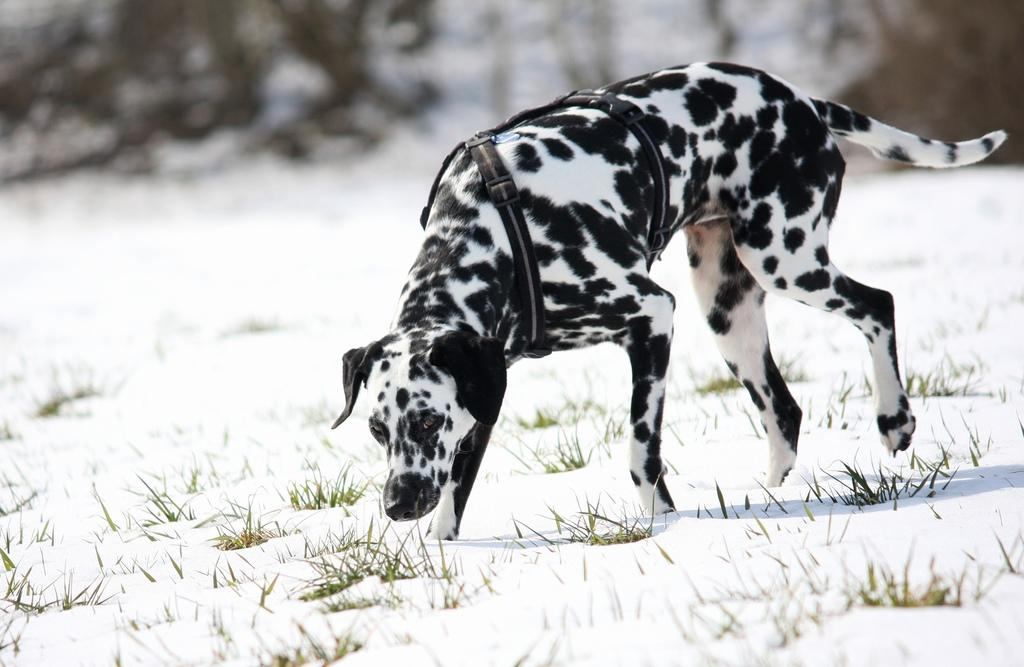What type of animal is in the image? There is a dog in the image. What is the dog wearing? The dog is wearing a belt. What is the dog doing in the image? The dog is walking on the ground. What type of terrain is the dog walking on? The ground is covered in snow, and there is grass on the ground. How would you describe the background of the image? The background of the image is blurred. Can you see any clouds in the image? There are no clouds visible in the image; the background is blurred. Is there a bear in the image? No, there is no bear present in the image; it features a dog wearing a belt. 